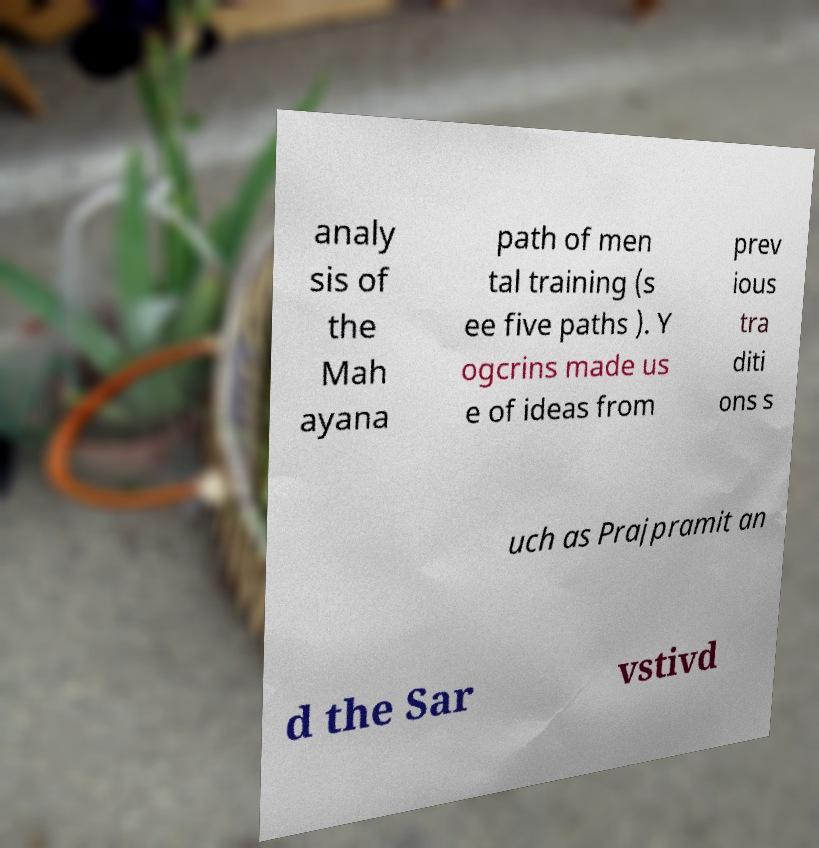Could you assist in decoding the text presented in this image and type it out clearly? analy sis of the Mah ayana path of men tal training (s ee five paths ). Y ogcrins made us e of ideas from prev ious tra diti ons s uch as Prajpramit an d the Sar vstivd 